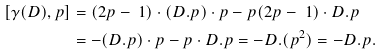<formula> <loc_0><loc_0><loc_500><loc_500>[ \gamma ( D ) , p ] & = ( 2 p - \ 1 ) \cdot ( D . p ) \cdot p - p ( 2 p - \ 1 ) \cdot D . p \\ & = - ( D . p ) \cdot p - p \cdot D . p = - D . ( p ^ { 2 } ) = - D . p .</formula> 